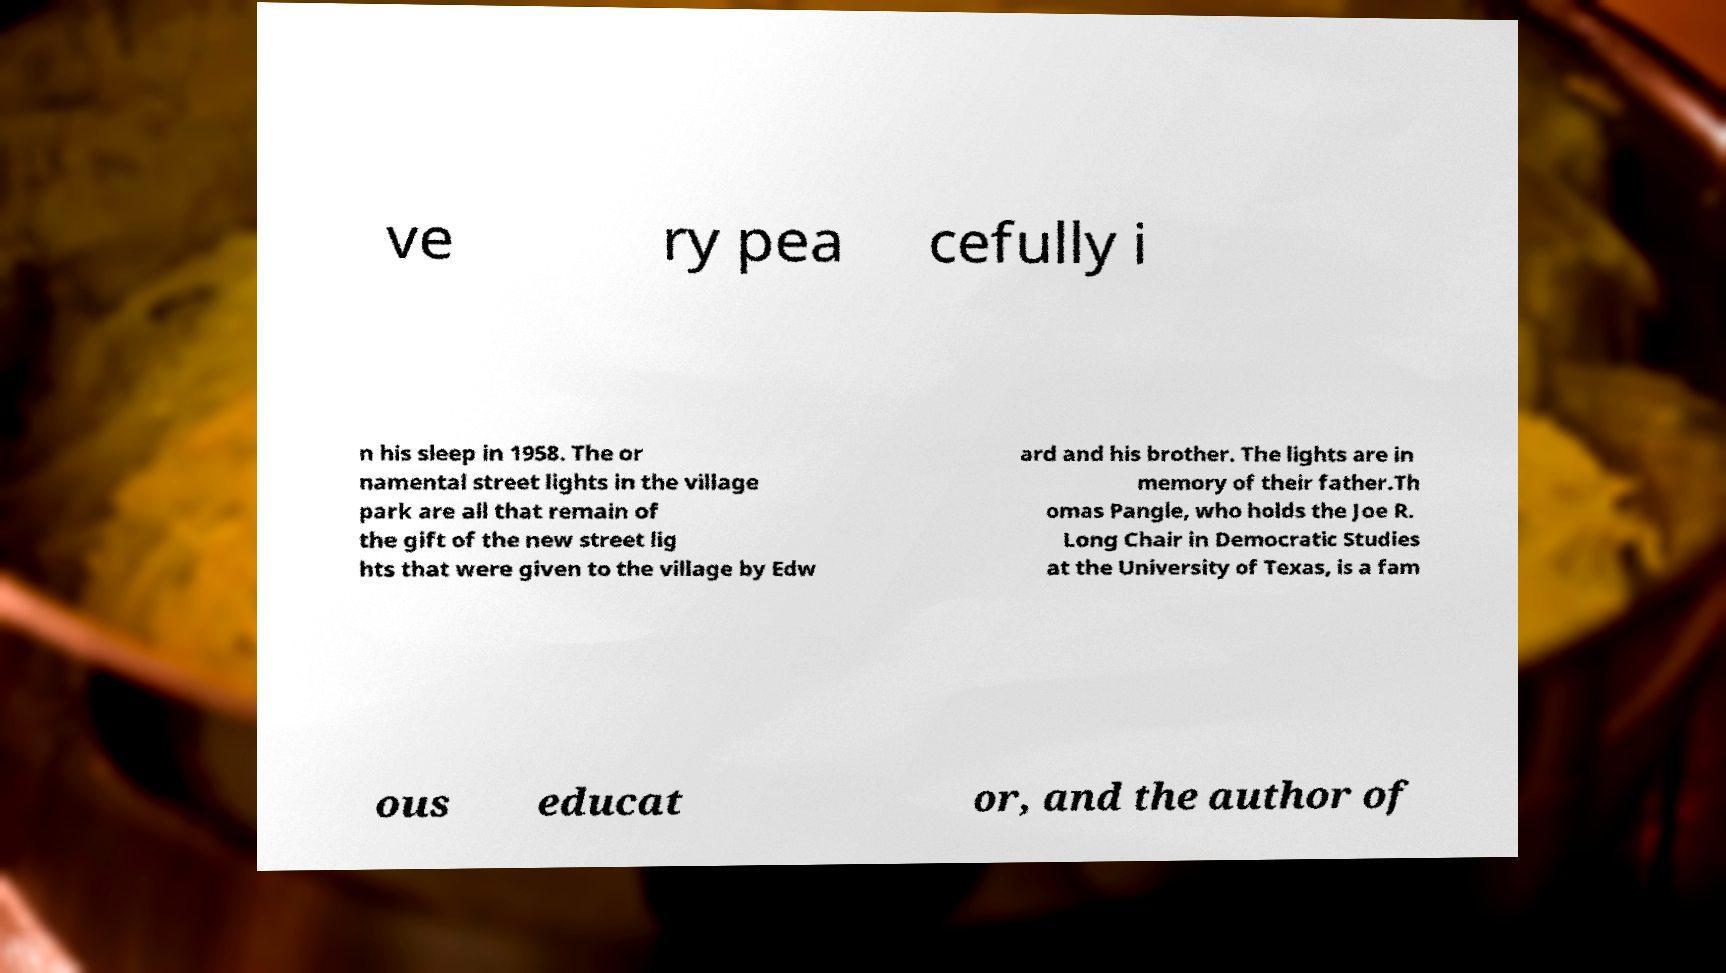Could you assist in decoding the text presented in this image and type it out clearly? ve ry pea cefully i n his sleep in 1958. The or namental street lights in the village park are all that remain of the gift of the new street lig hts that were given to the village by Edw ard and his brother. The lights are in memory of their father.Th omas Pangle, who holds the Joe R. Long Chair in Democratic Studies at the University of Texas, is a fam ous educat or, and the author of 